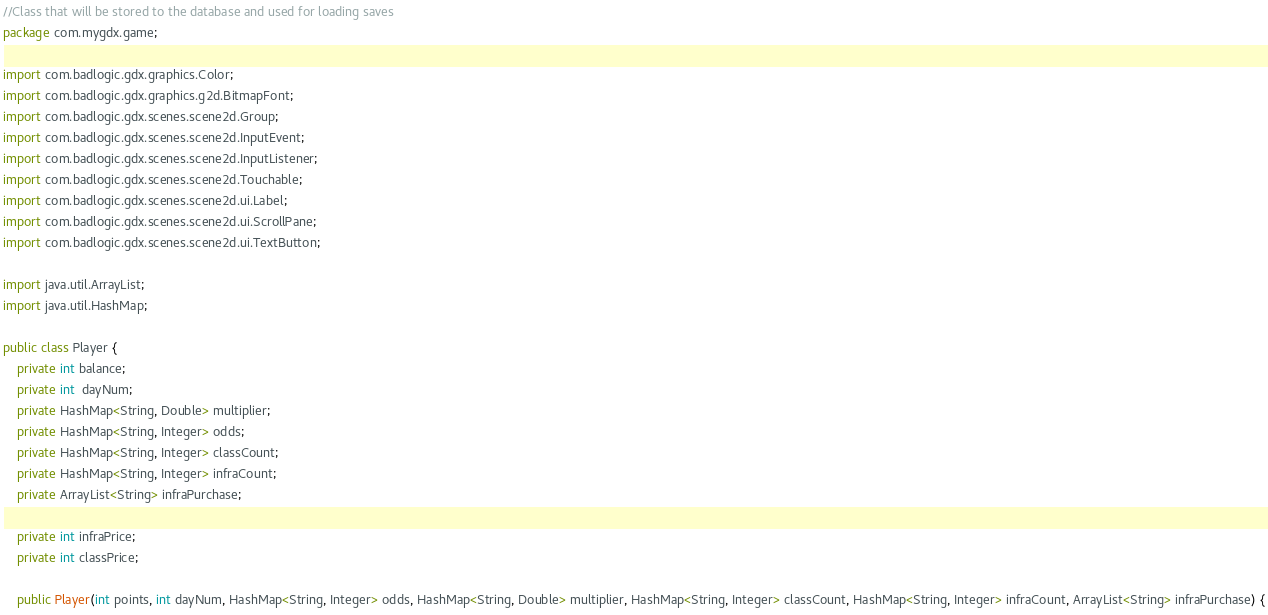Convert code to text. <code><loc_0><loc_0><loc_500><loc_500><_Java_>//Class that will be stored to the database and used for loading saves
package com.mygdx.game;

import com.badlogic.gdx.graphics.Color;
import com.badlogic.gdx.graphics.g2d.BitmapFont;
import com.badlogic.gdx.scenes.scene2d.Group;
import com.badlogic.gdx.scenes.scene2d.InputEvent;
import com.badlogic.gdx.scenes.scene2d.InputListener;
import com.badlogic.gdx.scenes.scene2d.Touchable;
import com.badlogic.gdx.scenes.scene2d.ui.Label;
import com.badlogic.gdx.scenes.scene2d.ui.ScrollPane;
import com.badlogic.gdx.scenes.scene2d.ui.TextButton;

import java.util.ArrayList;
import java.util.HashMap;

public class Player {
    private int balance;
    private int  dayNum;
    private HashMap<String, Double> multiplier;
    private HashMap<String, Integer> odds;
    private HashMap<String, Integer> classCount;
    private HashMap<String, Integer> infraCount;
    private ArrayList<String> infraPurchase;

    private int infraPrice;
    private int classPrice;

    public Player(int points, int dayNum, HashMap<String, Integer> odds, HashMap<String, Double> multiplier, HashMap<String, Integer> classCount, HashMap<String, Integer> infraCount, ArrayList<String> infraPurchase) {</code> 